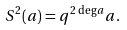Convert formula to latex. <formula><loc_0><loc_0><loc_500><loc_500>S ^ { 2 } ( a ) = q ^ { 2 \, \deg a } a .</formula> 